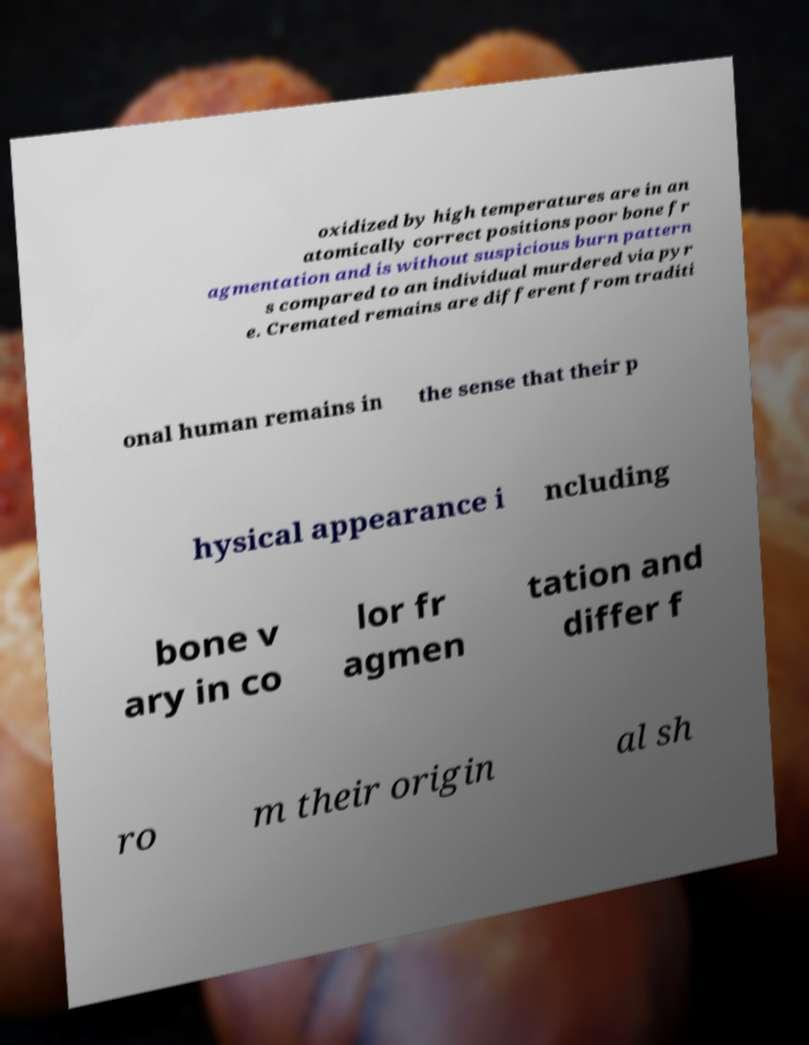Can you accurately transcribe the text from the provided image for me? oxidized by high temperatures are in an atomically correct positions poor bone fr agmentation and is without suspicious burn pattern s compared to an individual murdered via pyr e. Cremated remains are different from traditi onal human remains in the sense that their p hysical appearance i ncluding bone v ary in co lor fr agmen tation and differ f ro m their origin al sh 